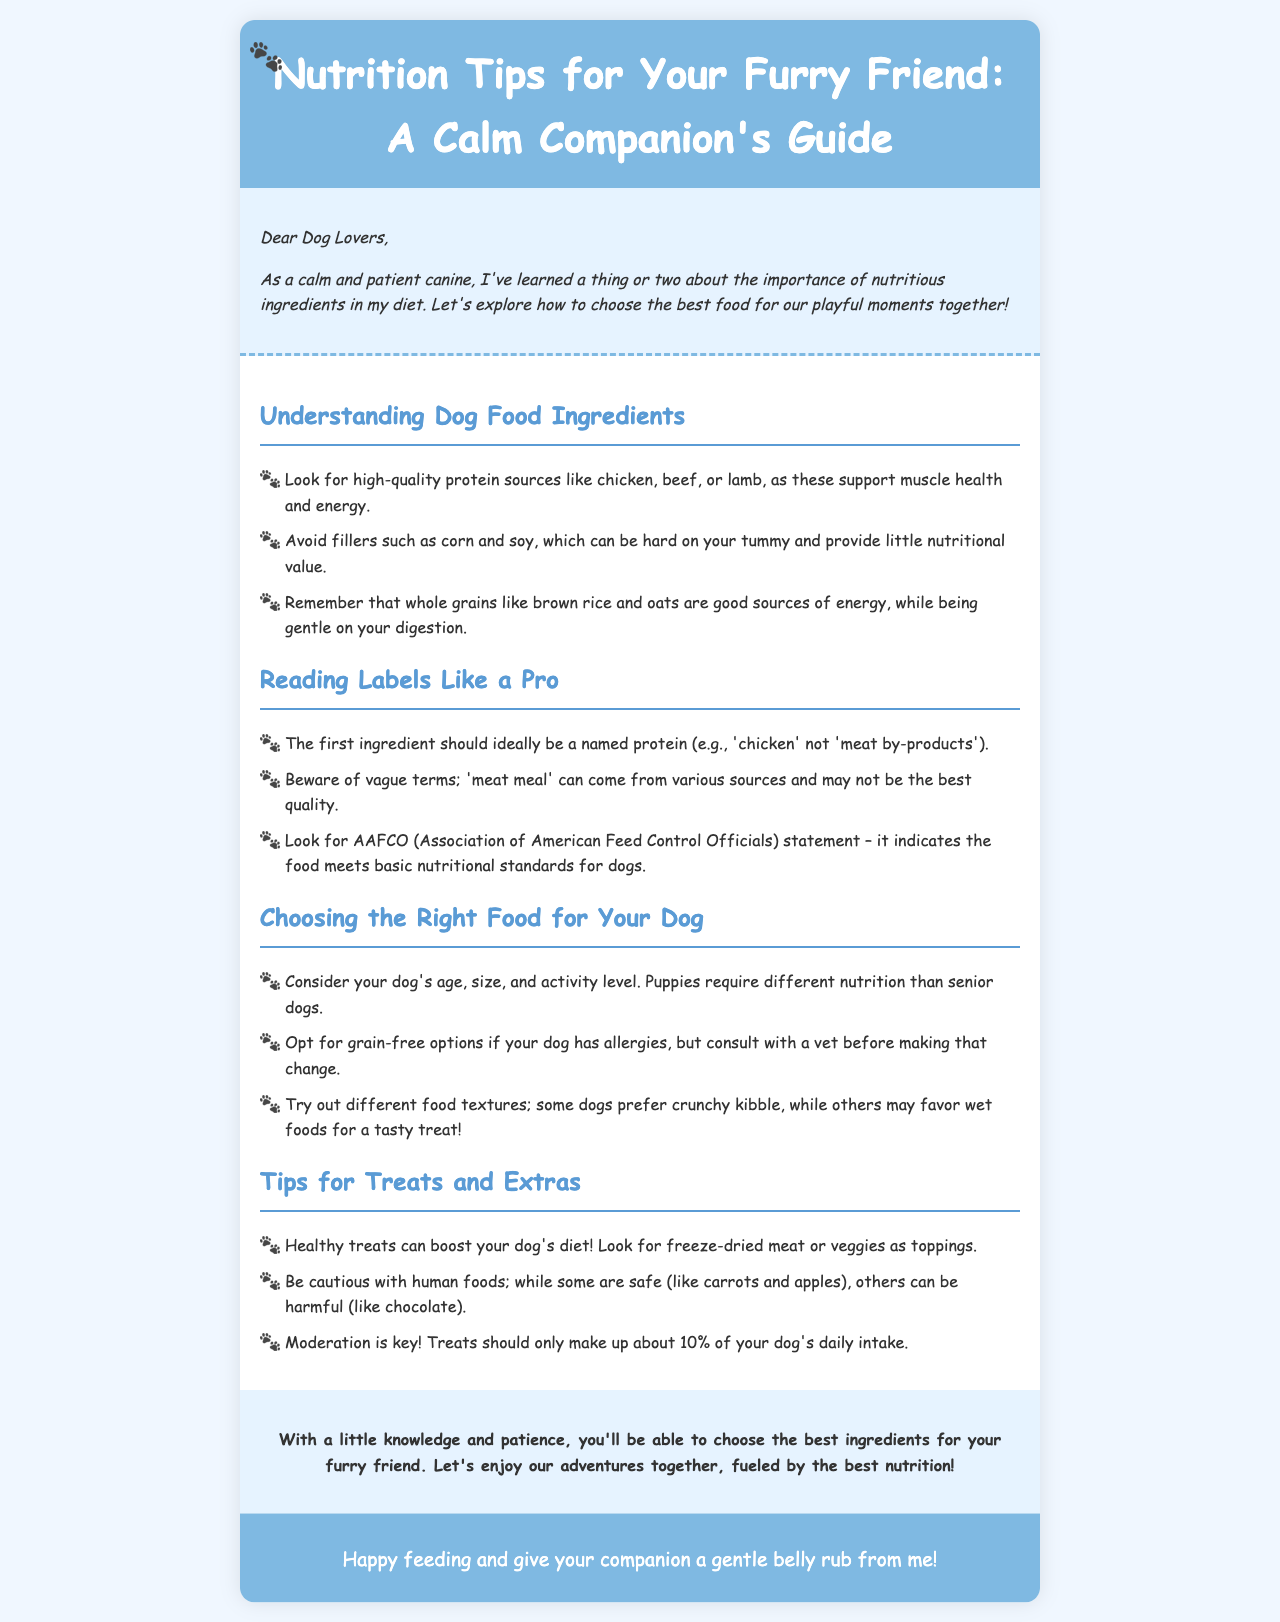What is the title of the newsletter? The title is the main heading of the document that summarizes its content about pet nutrition.
Answer: Nutrition Tips for Your Furry Friend: A Calm Companion's Guide What should the first ingredient be according to the document? The first ingredient is important in dog food and should ideally be a specific named protein.
Answer: A named protein What can healthy treats boost in a dog's diet? Healthy treats are suggested to enhance or improve a certain aspect of a dog's nutritional intake.
Answer: Nutritional value What is a good source of energy mentioned in the document? The document lists various ingredients and specifically mentions one type of food that provides energy while being easy to digest.
Answer: Whole grains How much of a dog's daily intake should treats make up? The newsletter emphasizes moderation in feeding treats and specifies a proportion of the overall daily food intake that treats should represent.
Answer: About 10% 